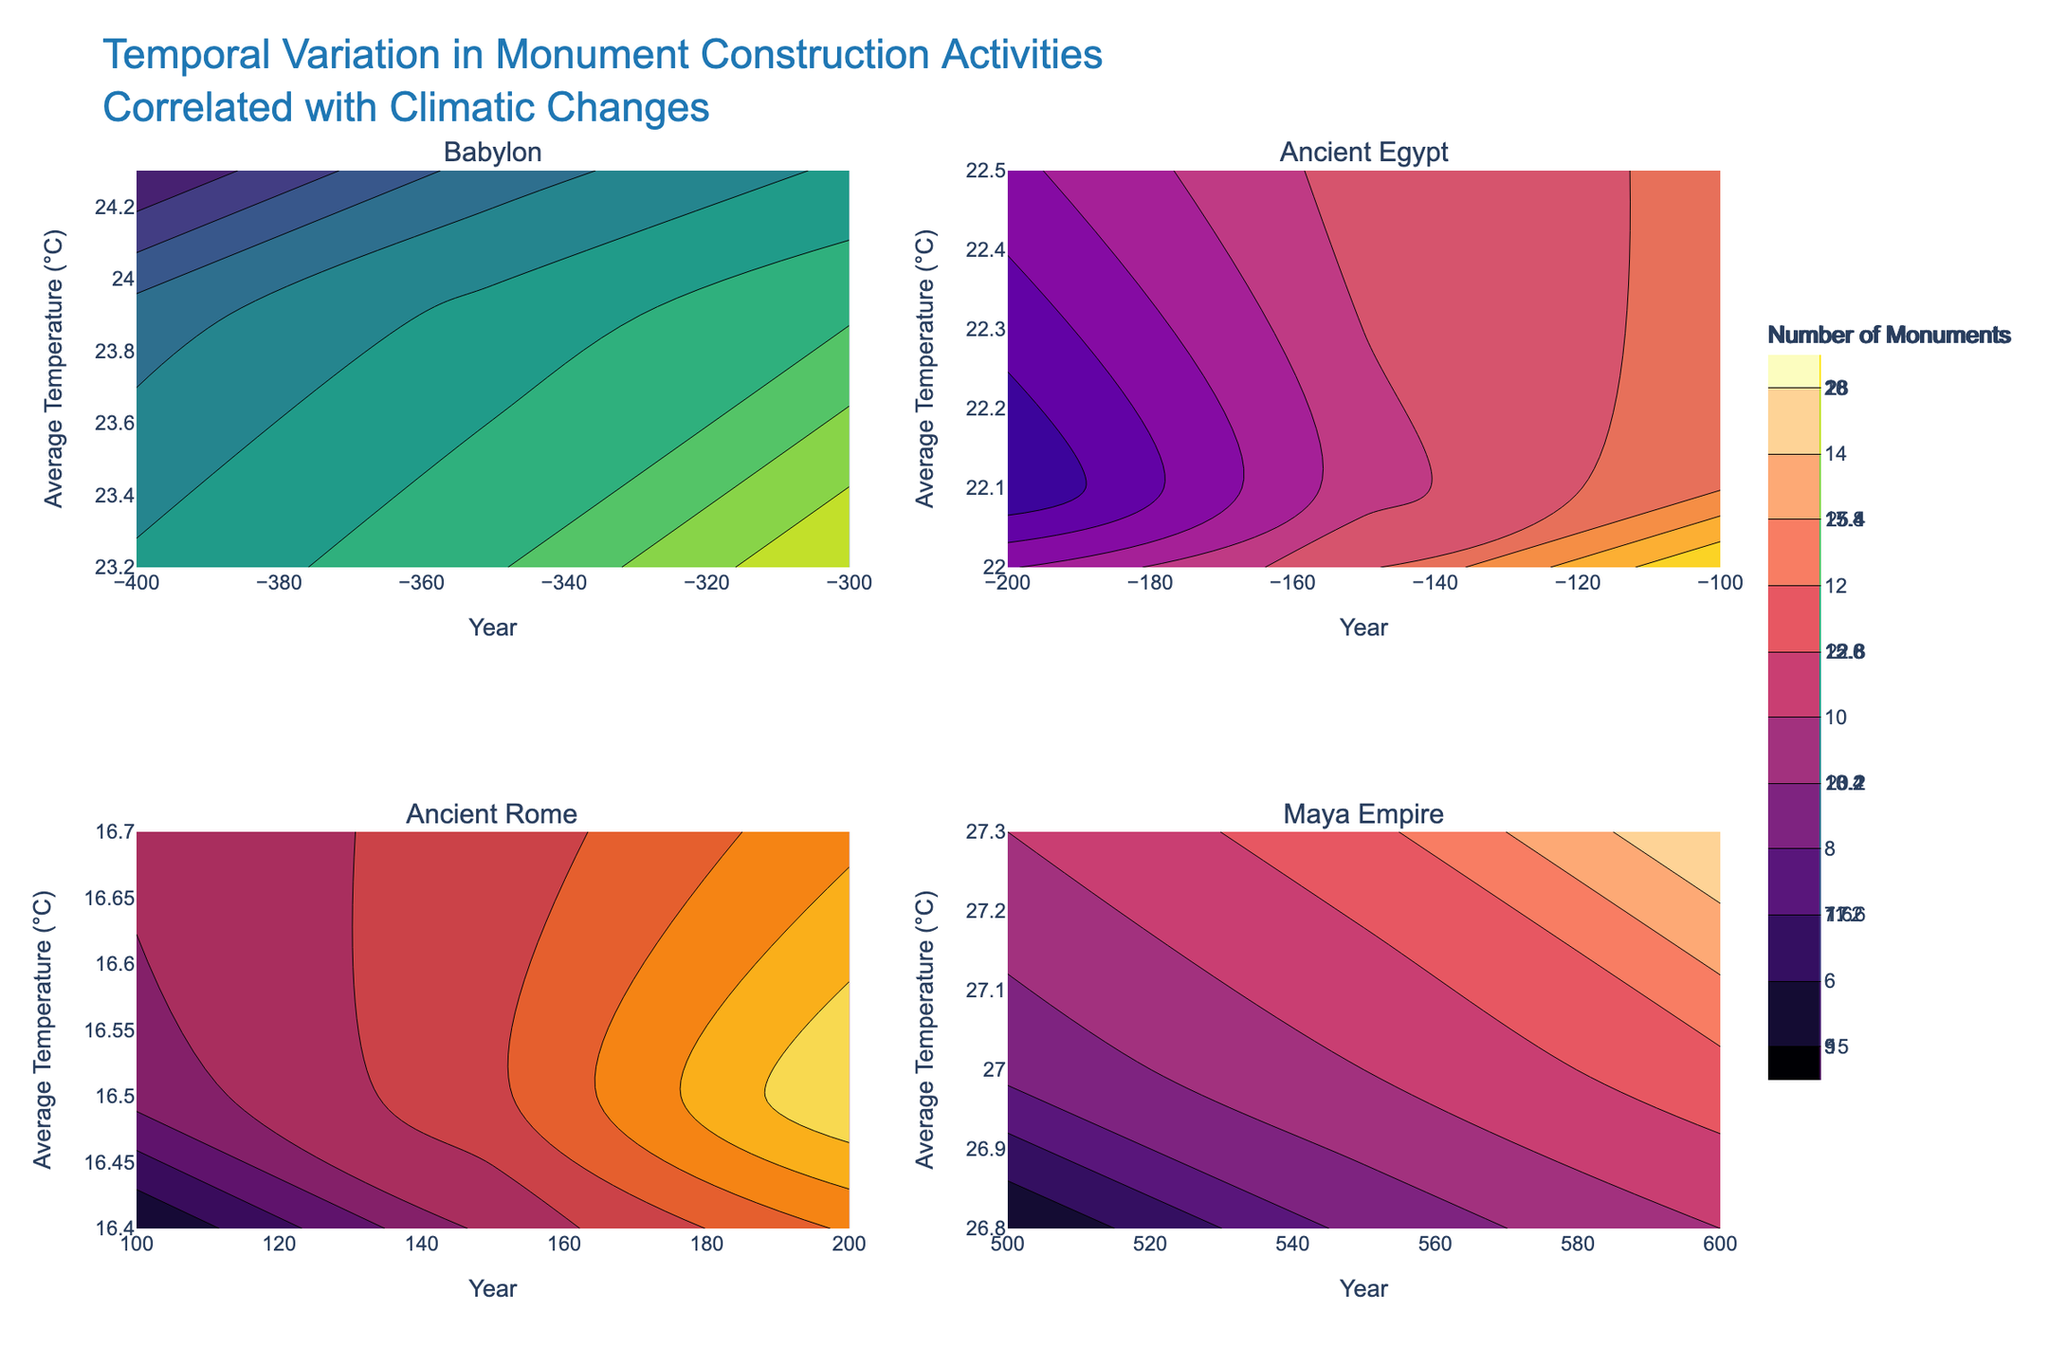What is the title of the figure? The title is located at the top of the figure, and it states the main focus of the visualized data. The title is "Temporal Variation in Monument Construction Activities Correlated with Climatic Changes".
Answer: Temporal Variation in Monument Construction Activities Correlated with Climatic Changes Which region has the highest average temperature during the observed period? To determine this, we compare the average temperature ranges across the contour plots for all four regions: Babylon, Ancient Egypt, Ancient Rome, and the Maya Empire. The region with the highest average temperature consistently is the Maya Empire.
Answer: Maya Empire What is the shape of the contours in the subplot for Ancient Rome? The shape of the contours in Ancient Rome's subplot should be examined by looking at the 2D contour lines on the corresponding subplot. They are mostly elliptical, indicating variations in the number of monuments and the average temperature over time.
Answer: Elliptical How does the number of monuments change in Babylon as the average temperature decreases? In Babylon's subplot, as we observe the contours from higher to lower average temperatures, the number of monuments increases.
Answer: Increases Compare the number of monuments built in Ancient Egypt around 200 BC to those built in Ancient Rome around 200 AD. The number of monuments in the 2D contour plots shows 9 pyramids around 200 BC in Ancient Egypt and 18 aqueducts around 200 AD in Ancient Rome.
Answer: Ancient Rome had more monuments What was the average temperature when the highest number of monuments was constructed in the Maya Empire? By examining the Maya Empire's subplot, the highest number of monuments built (15) occurred when the average temperature was around 27.3°C.
Answer: 27.3°C Did the Maya Empire experience an increase in monument construction as the precipitation increased? Checking the Maya Empire subplot, we see that as the precipitation levels increased from 1700 mm to 1800 mm, the number of constructed monuments also increased proportionally.
Answer: Yes Between 100 AD and 200 AD, how did the number of aqueducts in Ancient Rome change? Observing the contours in Ancient Rome's subplot between 100 AD and 200 AD, the number of aqueducts increased from 5 to 18.
Answer: Increased What is the minimum number of monuments built in Babylon within the observed timeframe? Looking at the lowest contour level in the Babylon subplot, the minimum number of monuments built in this region is 15.
Answer: 15 